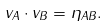Convert formula to latex. <formula><loc_0><loc_0><loc_500><loc_500>v _ { A } \cdot v _ { B } = \eta _ { A B } .</formula> 